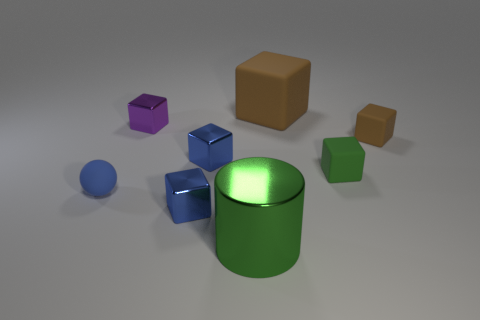Subtract all brown blocks. How many blocks are left? 4 Subtract all brown matte blocks. How many blocks are left? 4 Subtract all gray cubes. Subtract all green cylinders. How many cubes are left? 6 Add 1 tiny green rubber cubes. How many objects exist? 9 Subtract all cylinders. How many objects are left? 7 Subtract all big cylinders. Subtract all cylinders. How many objects are left? 6 Add 6 small brown matte objects. How many small brown matte objects are left? 7 Add 8 small purple shiny objects. How many small purple shiny objects exist? 9 Subtract 2 brown cubes. How many objects are left? 6 